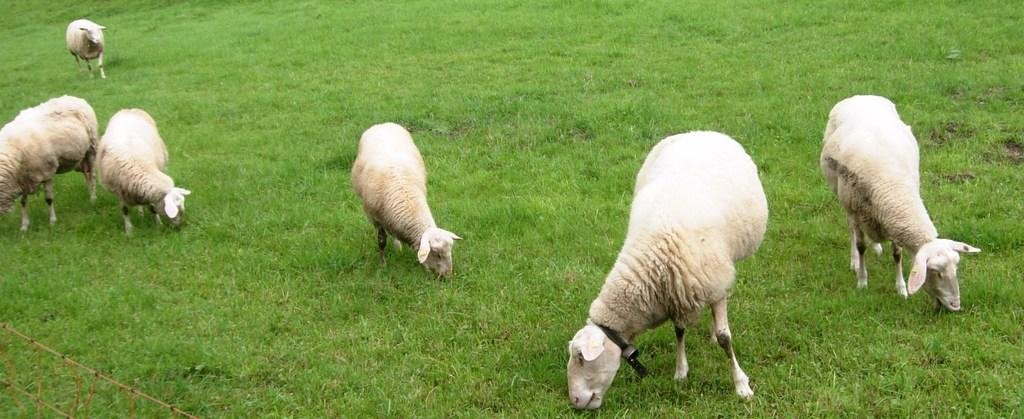What types of living organisms can be seen in the image? There are animals in the image. What is the ground covered with in the image? There is grass on the ground in the image. How many snakes can be seen slithering through the grass in the image? There are no snakes visible in the image; only animals are mentioned. Is there a crook present in the image? There is no mention of a crook in the image, so it cannot be determined if one is present. 